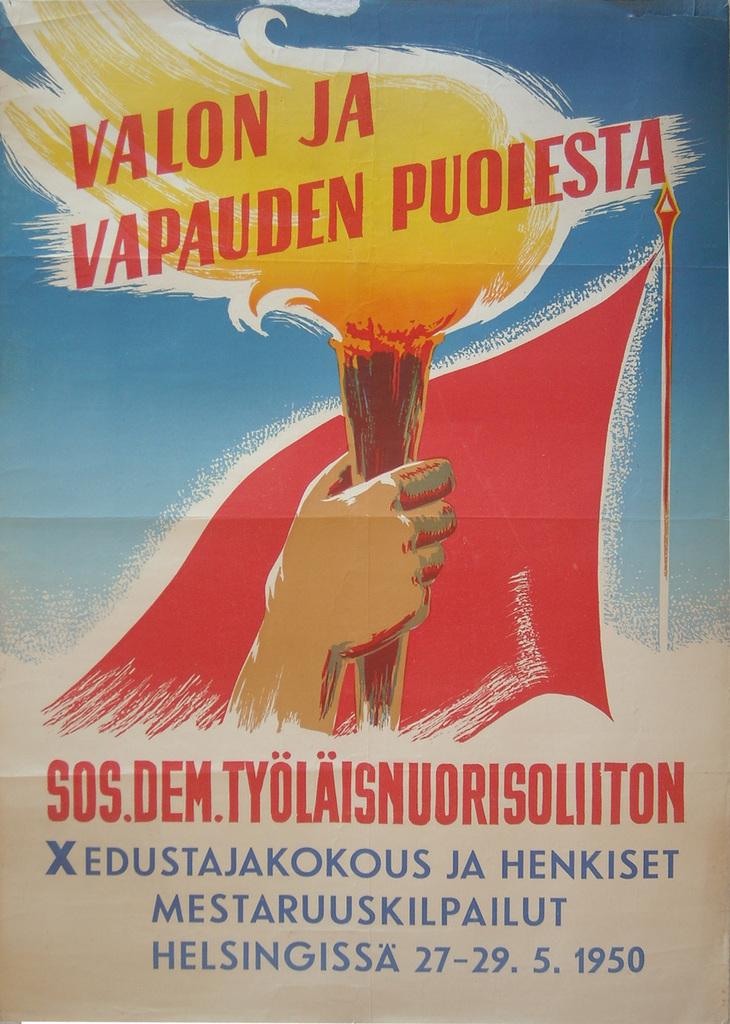What year is written on this poster?
Your answer should be very brief. 1950. Is this written in english?
Make the answer very short. No. 